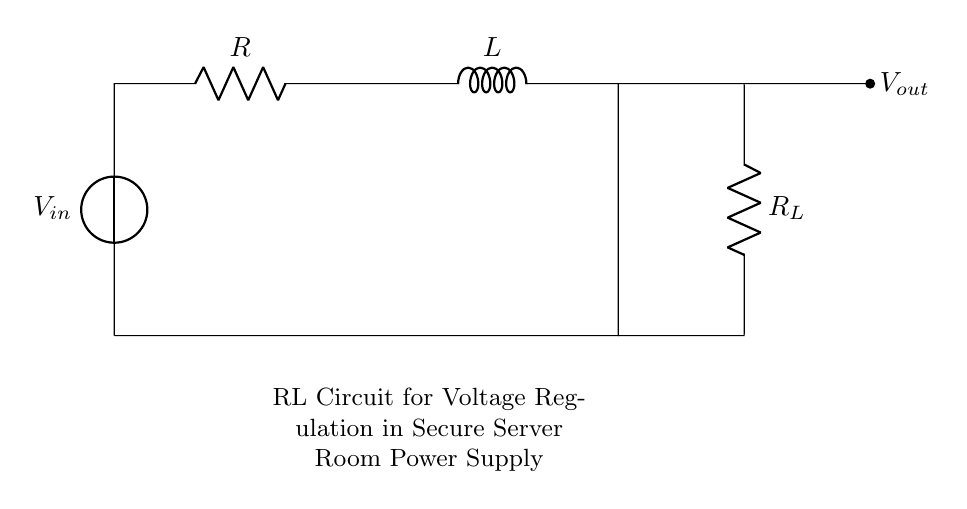What components are present in this circuit? The circuit contains a voltage source, a resistor (R), an inductor (L), and a load resistor (R_L). These components are connected in a loop, indicating their roles in voltage regulation.
Answer: voltage source, resistor, inductor, load resistor What is the role of the inductor in this RL circuit? The inductor in this RL circuit smooths out voltage fluctuations by storing energy in its magnetic field when current passes through it. This helps maintain stable voltage output.
Answer: energy storage What is the output voltage (V_out) in this circuit? The output voltage can be inferred from the circuit configuration. It is taken across the load resistor (R_L), and while the specific value is not provided in the diagram, V_out is the voltage drop across this component.
Answer: V_out is V across R_L How does increasing the resistance (R) affect the circuit? Increasing resistance R will decrease the current in the circuit according to Ohm's law (I = V/R), leading to reduced energy supplied to the inductor and consequently affecting the voltage output at V_out.
Answer: decreases current What is the expected behavior of this RL circuit when power is first applied? When power is first applied, the inductor resists sudden changes in current, causing a delay in reaching maximum current. This behavior is known as inductive reactance, which gradually allows the current to rise until it stabilizes.
Answer: current ramp-up What happens if the load resistance (R_L) is very low? A very low load resistance (R_L) would lead to a high current draw, which can increase energy consumption and generate heat in the circuit. This can potentially damage components and affect voltage regulation.
Answer: high current draw What kind of applications is this circuit typically used for? This RL circuit is typically used in applications requiring stable voltage outputs, such as in power supply units for secure server rooms, which need reliable operation to prevent data breaches or failures.
Answer: power supply for secure servers 